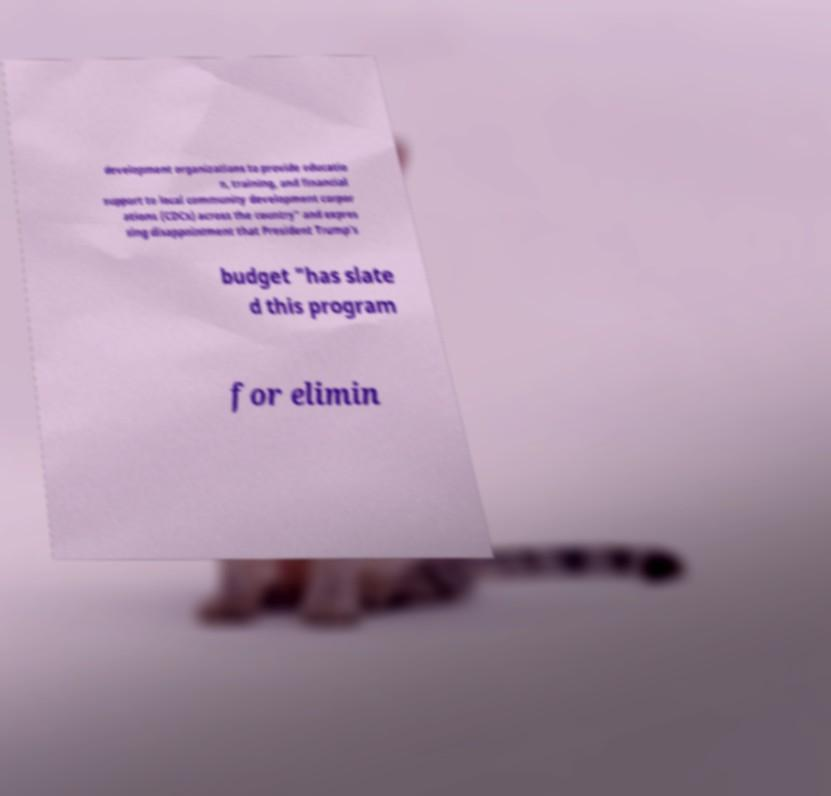Please read and relay the text visible in this image. What does it say? development organizations to provide educatio n, training, and financial support to local community development corpor ations (CDCs) across the country" and expres sing disappointment that President Trump's budget "has slate d this program for elimin 